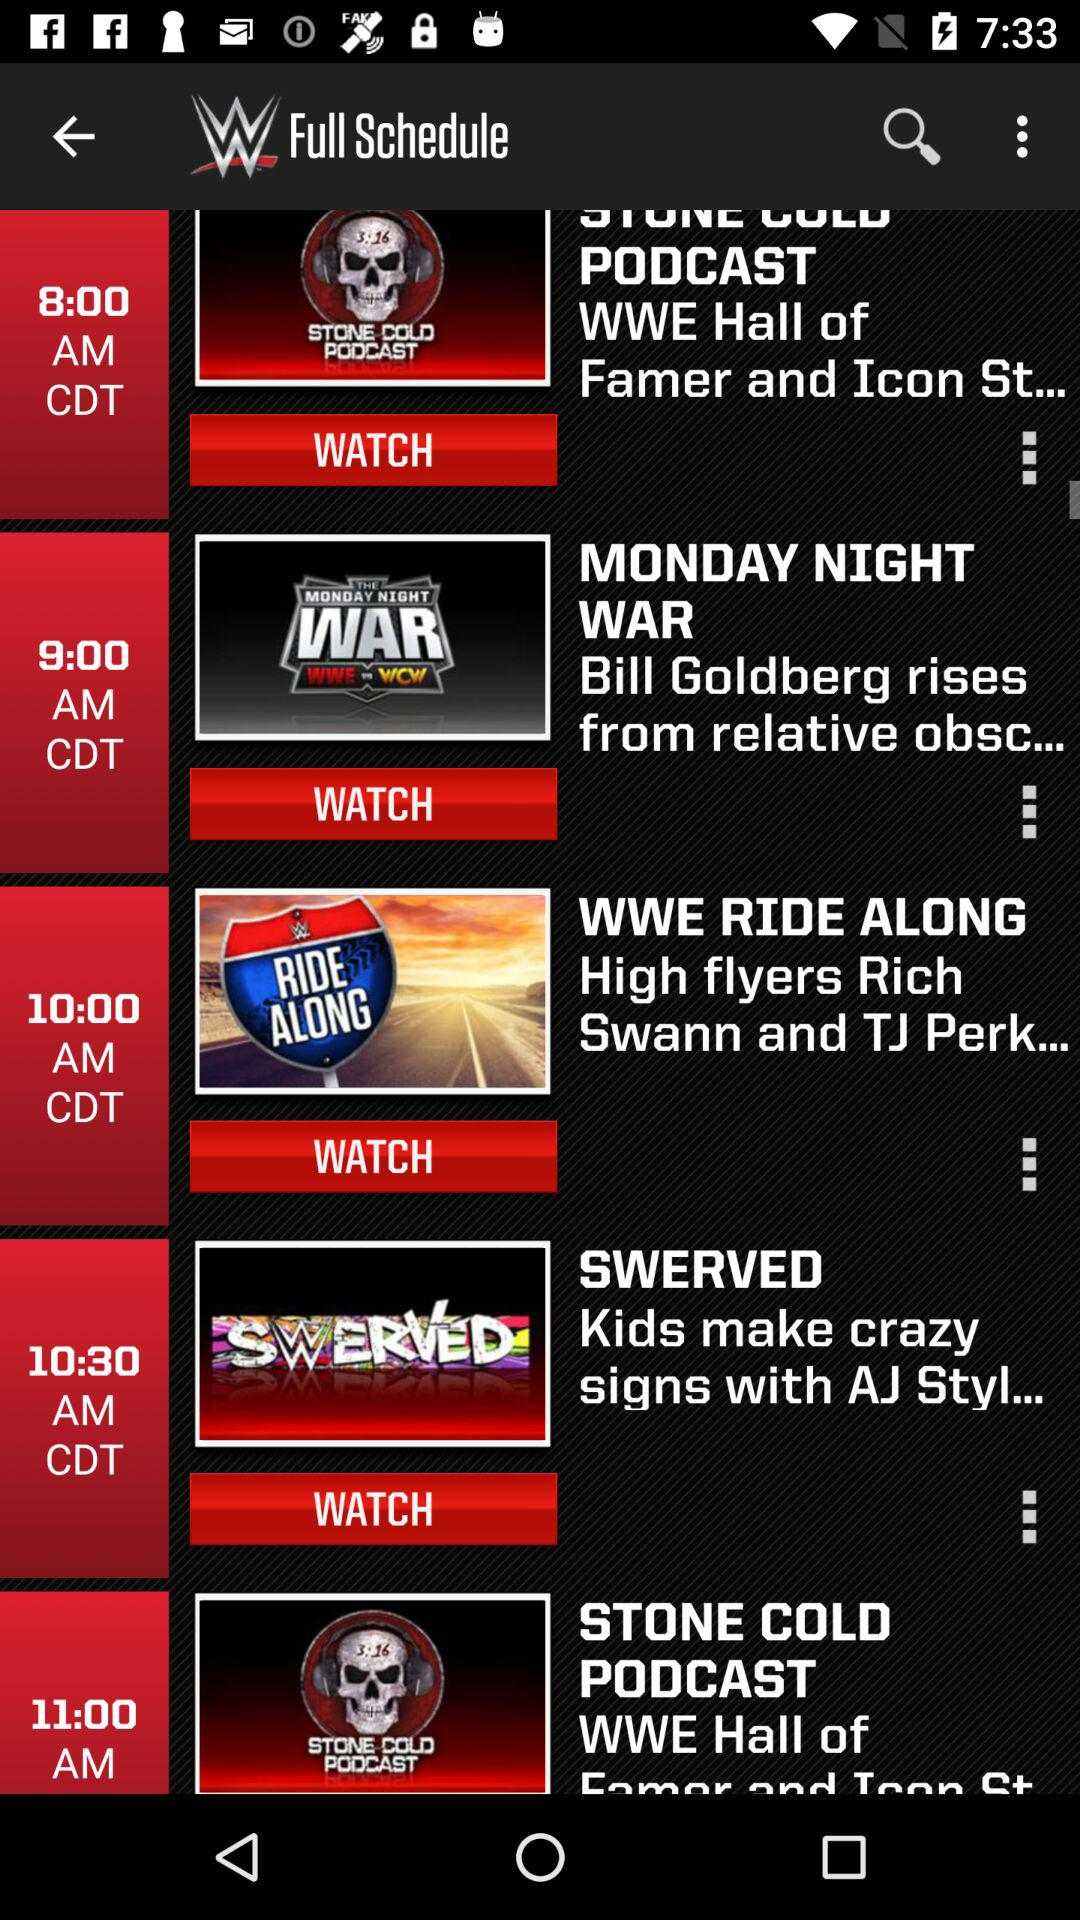What is the time of "MONDAY NIGHT WAR"? The time is 9:00 AM. 